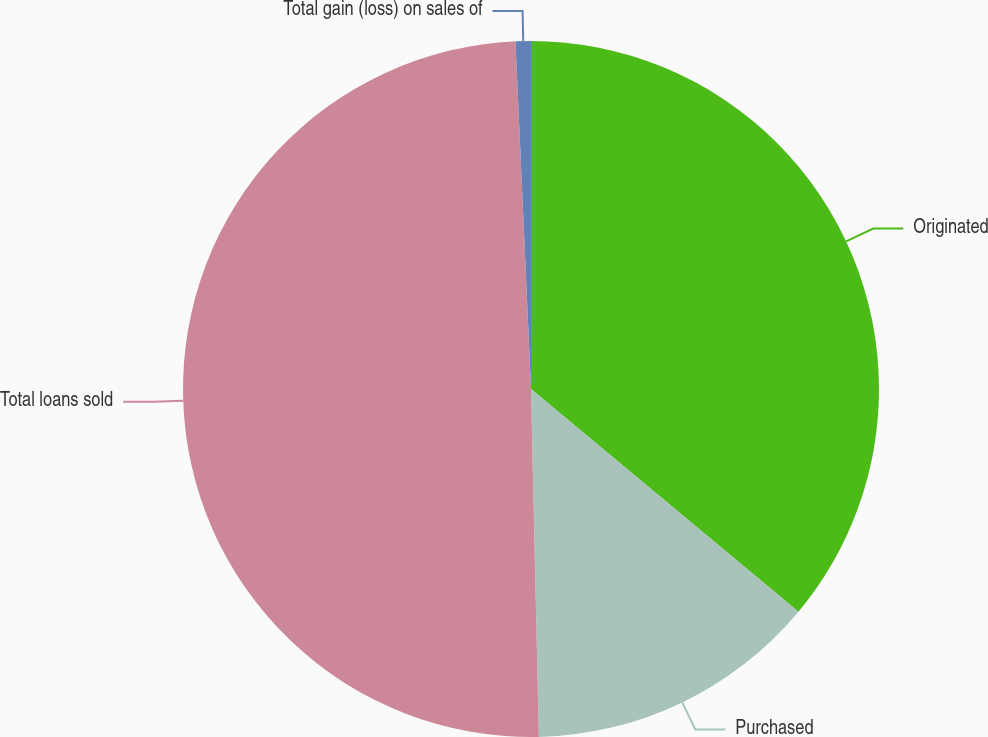Convert chart to OTSL. <chart><loc_0><loc_0><loc_500><loc_500><pie_chart><fcel>Originated<fcel>Purchased<fcel>Total loans sold<fcel>Total gain (loss) on sales of<nl><fcel>36.05%<fcel>13.59%<fcel>49.65%<fcel>0.71%<nl></chart> 